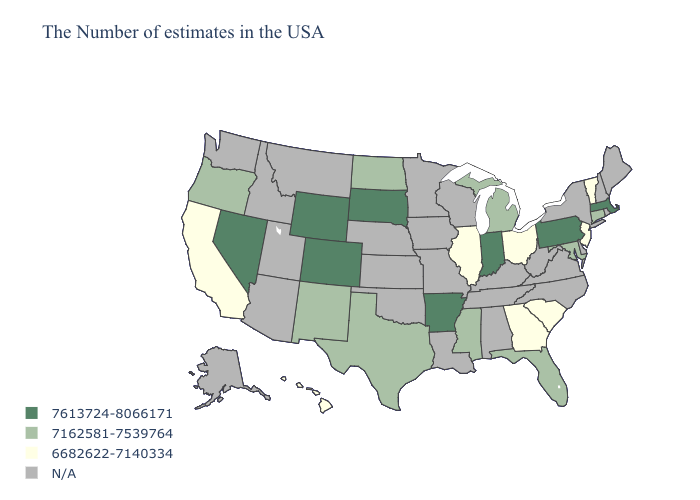What is the value of Minnesota?
Short answer required. N/A. Name the states that have a value in the range N/A?
Keep it brief. Maine, Rhode Island, New Hampshire, New York, Delaware, Virginia, North Carolina, West Virginia, Kentucky, Alabama, Tennessee, Wisconsin, Louisiana, Missouri, Minnesota, Iowa, Kansas, Nebraska, Oklahoma, Utah, Montana, Arizona, Idaho, Washington, Alaska. What is the lowest value in the South?
Give a very brief answer. 6682622-7140334. What is the value of Wyoming?
Write a very short answer. 7613724-8066171. Among the states that border North Carolina , which have the highest value?
Concise answer only. South Carolina, Georgia. Does New Jersey have the lowest value in the Northeast?
Keep it brief. Yes. Name the states that have a value in the range N/A?
Give a very brief answer. Maine, Rhode Island, New Hampshire, New York, Delaware, Virginia, North Carolina, West Virginia, Kentucky, Alabama, Tennessee, Wisconsin, Louisiana, Missouri, Minnesota, Iowa, Kansas, Nebraska, Oklahoma, Utah, Montana, Arizona, Idaho, Washington, Alaska. What is the highest value in the West ?
Short answer required. 7613724-8066171. What is the value of Utah?
Concise answer only. N/A. What is the highest value in states that border Ohio?
Short answer required. 7613724-8066171. What is the value of California?
Concise answer only. 6682622-7140334. Does Maryland have the lowest value in the USA?
Quick response, please. No. What is the lowest value in states that border Maryland?
Give a very brief answer. 7613724-8066171. What is the highest value in the USA?
Be succinct. 7613724-8066171. What is the value of Michigan?
Quick response, please. 7162581-7539764. 